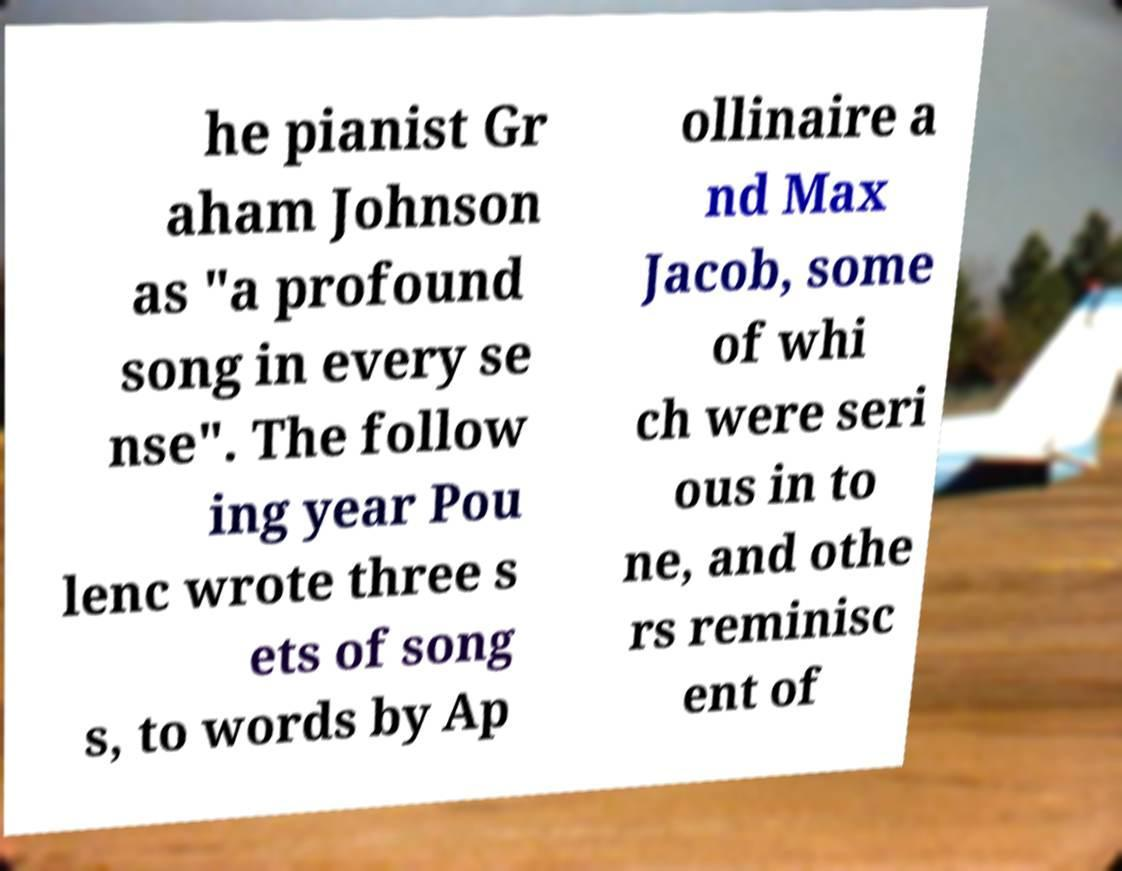I need the written content from this picture converted into text. Can you do that? he pianist Gr aham Johnson as "a profound song in every se nse". The follow ing year Pou lenc wrote three s ets of song s, to words by Ap ollinaire a nd Max Jacob, some of whi ch were seri ous in to ne, and othe rs reminisc ent of 